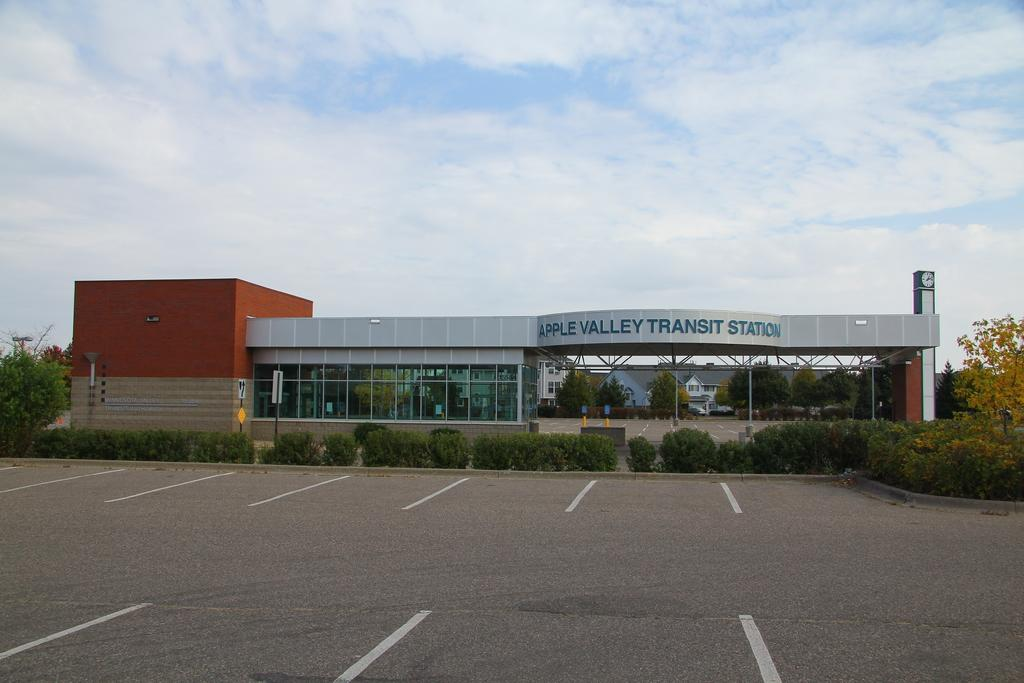<image>
Summarize the visual content of the image. a building with an empty parking lot and the name apple valley transit station 